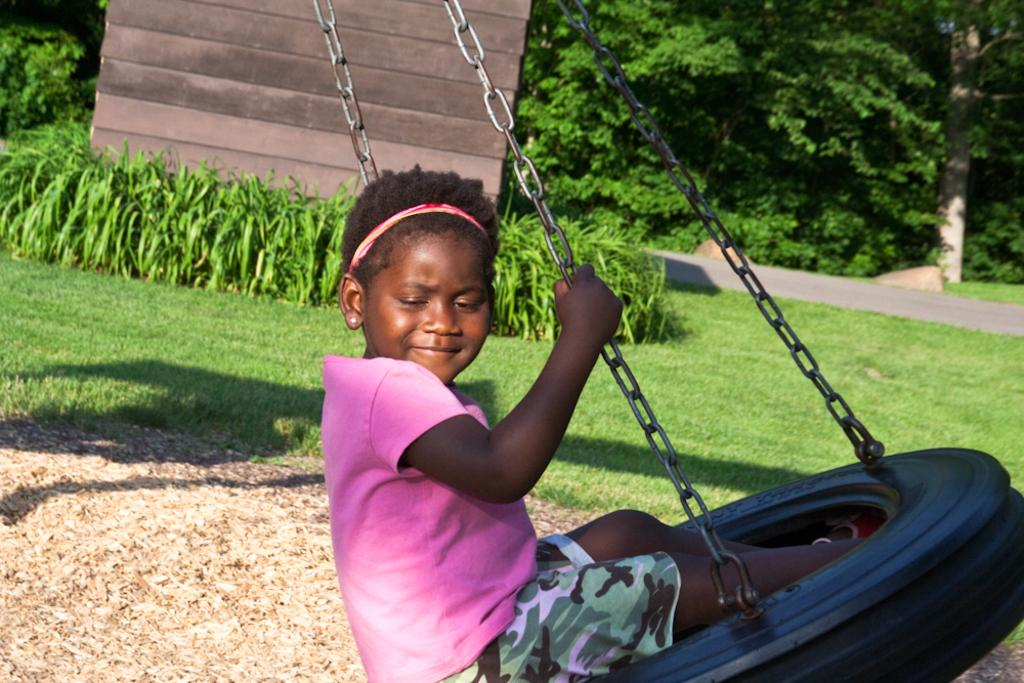Who is present in the image? There is a girl in the image. What is the girl doing in the image? The girl is sitting on a swing. What is the girl's expression in the image? The girl is smiling. What type of surface is visible beneath the girl? There is grass visible in the image. What other types of vegetation can be seen in the image? There are plants in the image. What is the background of the image composed of? There is a wall and trees in the background of the image. What type of temper does the girl have in the image? There is no indication of the girl's temper in the image; we can only observe her smiling expression. Can you see any fairies flying around the girl in the image? There are no fairies present in the image. 